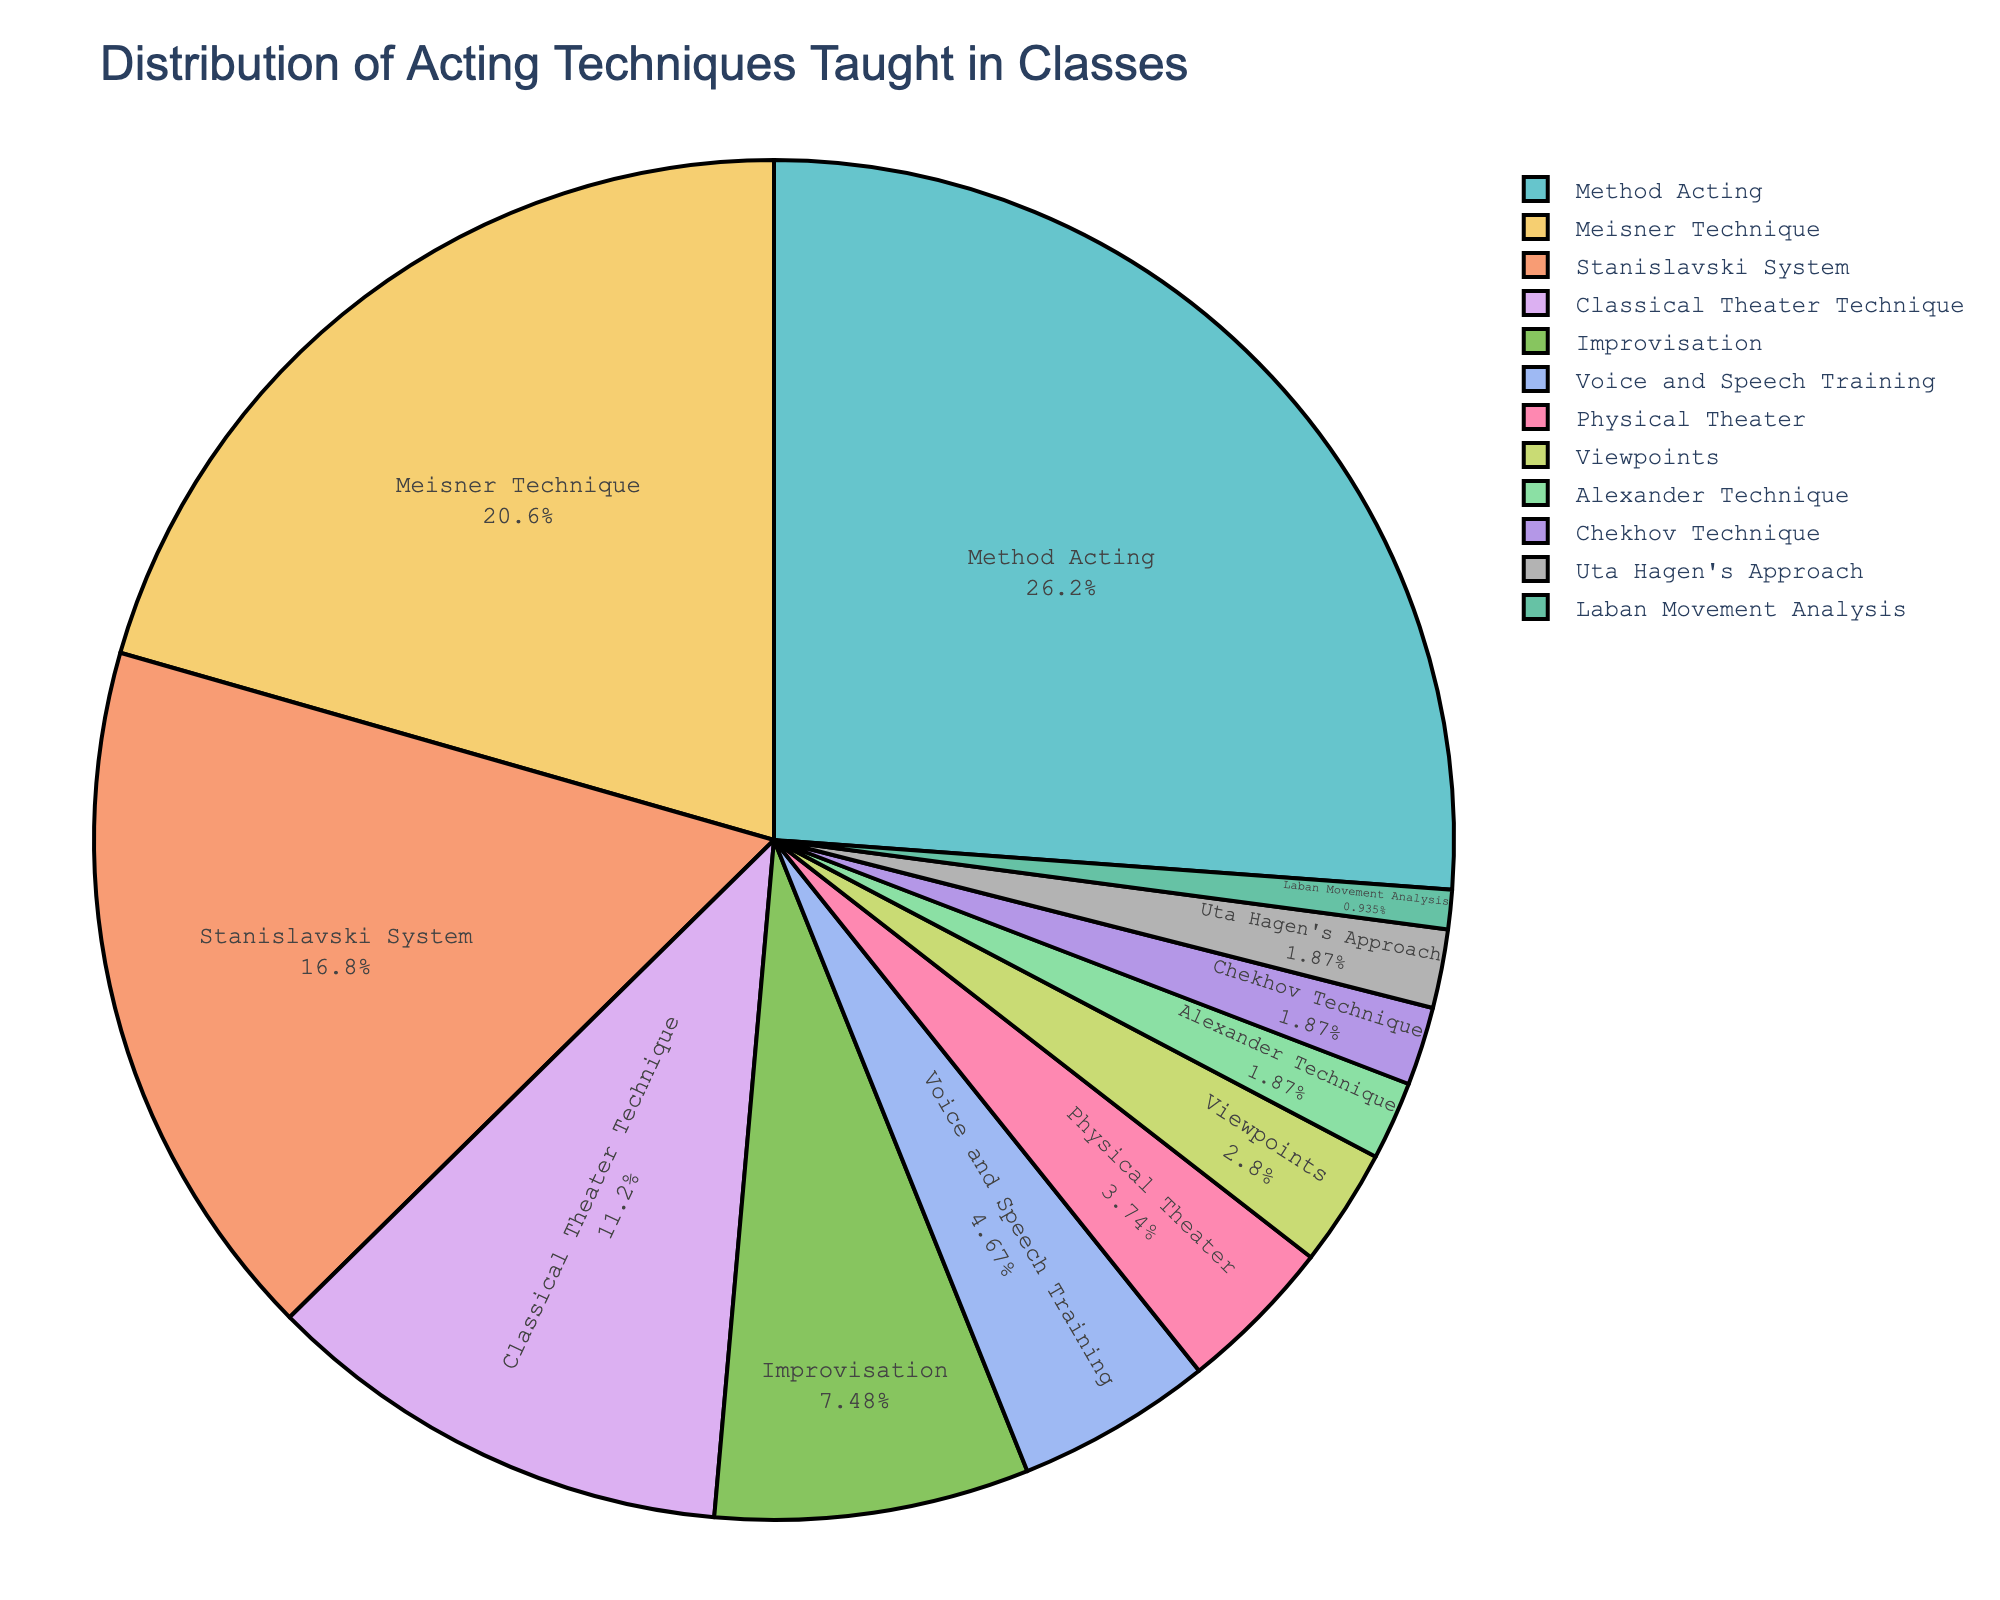Which acting technique has the highest percentage? The segment with the largest size represents Method Acting, which is 28% of the total distribution.
Answer: Method Acting Which two techniques together make up exactly 10%? From the chart, Voice and Speech Training (5%) and Physical Theater (4%) sum up to 9%, which is close but not exactly 10%. Instead, Alexander Technique (2%) and Chekhov Technique (2%) add up to 4%. Laban Movement Analysis (1%) is not a direct pair with another. There's no pair that exactly sums up to 10%.
Answer: No such pair How much larger is the percentage for Method Acting compared to Meisner Technique? Method Acting has a percentage of 28% and Meisner Technique has 22%. The difference is 28% - 22% = 6%.
Answer: 6% Which technique shares an equal percentage with Uta Hagen's Approach? Both Uta Hagen's Approach and Alexander Technique have a percentage of 2%.
Answer: Alexander Technique What is the combined percentage of the top three techniques? The top three techniques are Method Acting (28%), Meisner Technique (22%), and Stanislavski System (18%). The combined percentage is 28% + 22% + 18% = 68%.
Answer: 68% Compare the percentage of Classical Theater Technique and Improvisation. Which one is larger and by how much? Classical Theater Technique is 12%, and Improvisation is 8%. The difference is 12% - 8% = 4%.
Answer: Classical Theater Technique by 4% What is the percentage difference between Voice and Speech Training and Viewpoints? Voice and Speech Training is at 5%, and Viewpoints is at 3%. The difference is 5% - 3% = 2%.
Answer: 2% Identify the techniques that make up less than 5% of the total distribution. Techniques with less than 5% are Physical Theater (4%), Viewpoints (3%), Alexander Technique (2%), Chekhov Technique (2%), Uta Hagen's Approach (2%), and Laban Movement Analysis (1%).
Answer: Physical Theater, Viewpoints, Alexander Technique, Chekhov Technique, Uta Hagen's Approach, Laban Movement Analysis Which technique uses the second least amount of the total distribution? Alexander Technique, Chekhov Technique, and Uta Hagen's Approach each have 2%. Laban Movement Analysis has the least at 1%, so the second least is tied among Alexander Technique, Chekhov Technique, and Uta Hagen's Approach.
Answer: Alexander Technique, Chekhov Technique, Uta Hagen's Approach How does the percentage of Method Acting compare to all techniques with less than 5% combined? Method Acting is 28%. The sum of techniques less than 5% is 4% (Physical Theater) + 3% (Viewpoints) + 2% (Alexander Technique) + 2% (Chekhov Technique) + 2% (Uta Hagen's Approach) + 1% (Laban Movement Analysis) = 14%. Method Acting (28%) is 28% - 14% = 14% more than the combined less than 5% techniques.
Answer: 14% more 